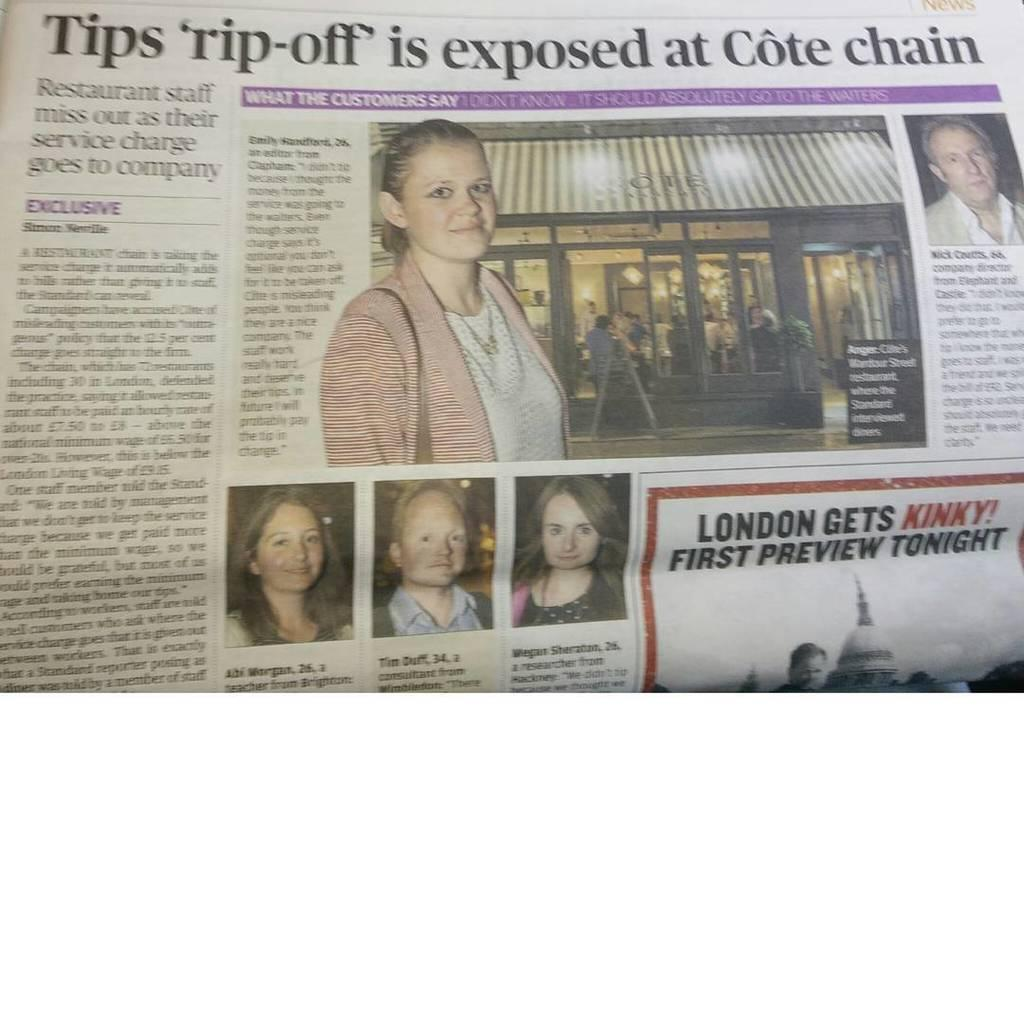What is the main object in the image? There is a newspaper in the image. What types of content can be found in the newspaper? The newspaper contains images and text. How long is the string used to tie the newspaper in the image? There is no string present in the image; the newspaper is not tied or bound in any way. 